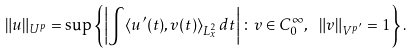<formula> <loc_0><loc_0><loc_500><loc_500>\| u \| _ { U ^ { p } } = \sup \left \{ \left | \int \langle u ^ { \prime } ( t ) , v ( t ) \rangle _ { L ^ { 2 } _ { x } } \, d t \right | \colon v \in C ^ { \infty } _ { 0 } , \ \| v \| _ { V ^ { p ^ { \prime } } } = 1 \right \} .</formula> 